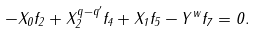Convert formula to latex. <formula><loc_0><loc_0><loc_500><loc_500>- X _ { 0 } f _ { 2 } + X _ { 2 } ^ { q - q ^ { \prime } } f _ { 4 } + X _ { 1 } f _ { 5 } - Y ^ { w } f _ { 7 } = 0 .</formula> 